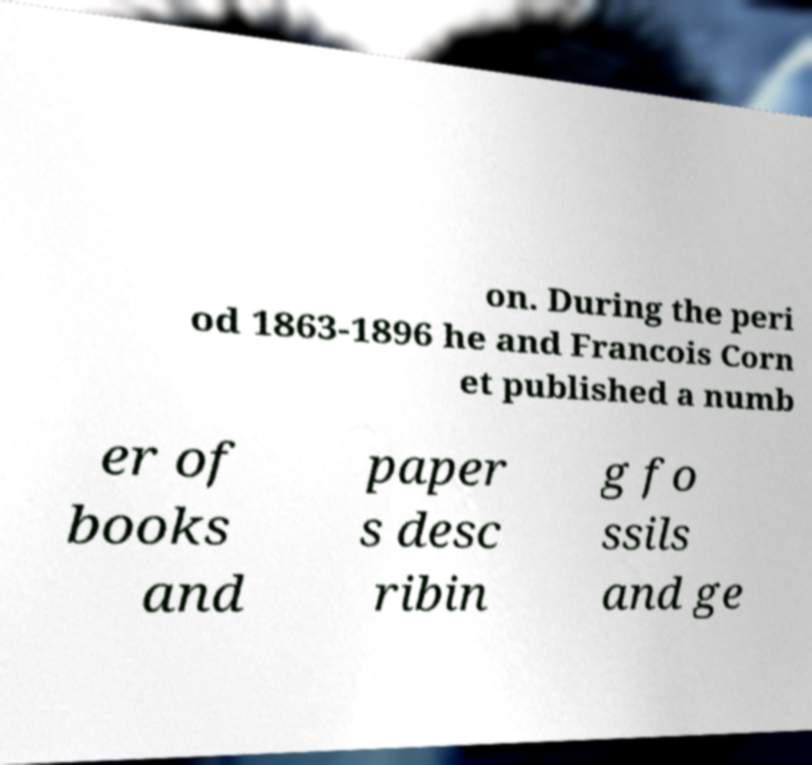Can you accurately transcribe the text from the provided image for me? on. During the peri od 1863-1896 he and Francois Corn et published a numb er of books and paper s desc ribin g fo ssils and ge 